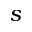<formula> <loc_0><loc_0><loc_500><loc_500>s</formula> 